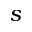<formula> <loc_0><loc_0><loc_500><loc_500>s</formula> 